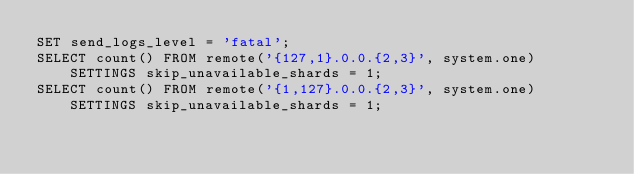Convert code to text. <code><loc_0><loc_0><loc_500><loc_500><_SQL_>SET send_logs_level = 'fatal';
SELECT count() FROM remote('{127,1}.0.0.{2,3}', system.one) SETTINGS skip_unavailable_shards = 1;
SELECT count() FROM remote('{1,127}.0.0.{2,3}', system.one) SETTINGS skip_unavailable_shards = 1;
</code> 